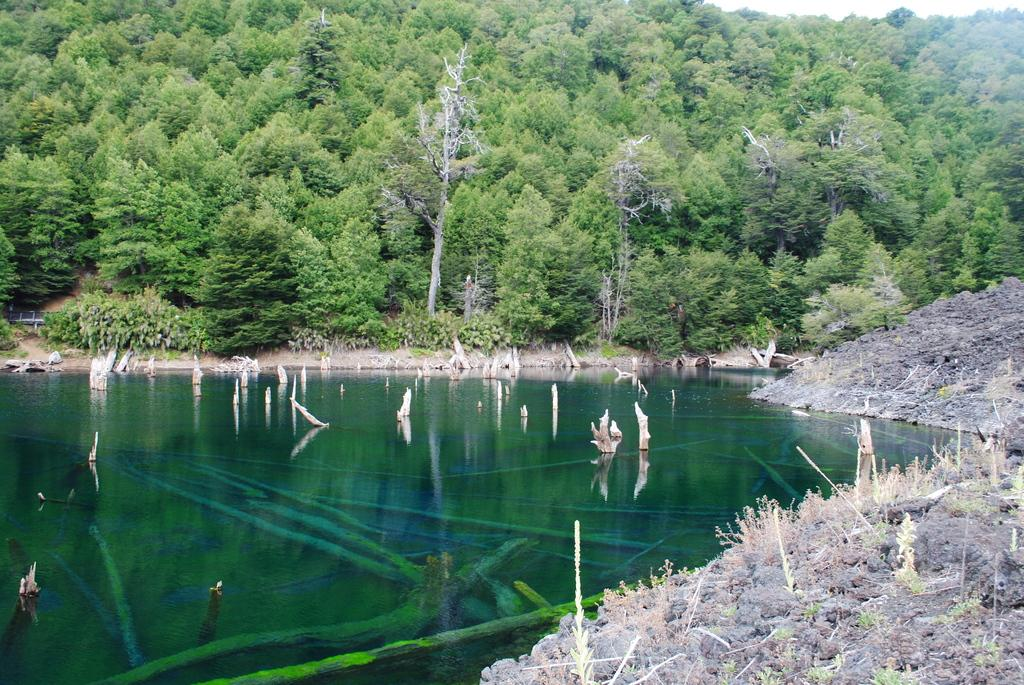What type of natural elements can be seen in the image? There are trees, hills, and water visible in the image. Can you describe the vegetation in the image? There are trees and twigs visible in the image. What is the terrain like in the image? The terrain includes hills and water. What type of competition is taking place in the image? There is no competition present in the image; it features natural elements such as trees, hills, and water. What branch can be seen supporting the twigs in the image? There is no branch visible in the image; only twigs are mentioned. 